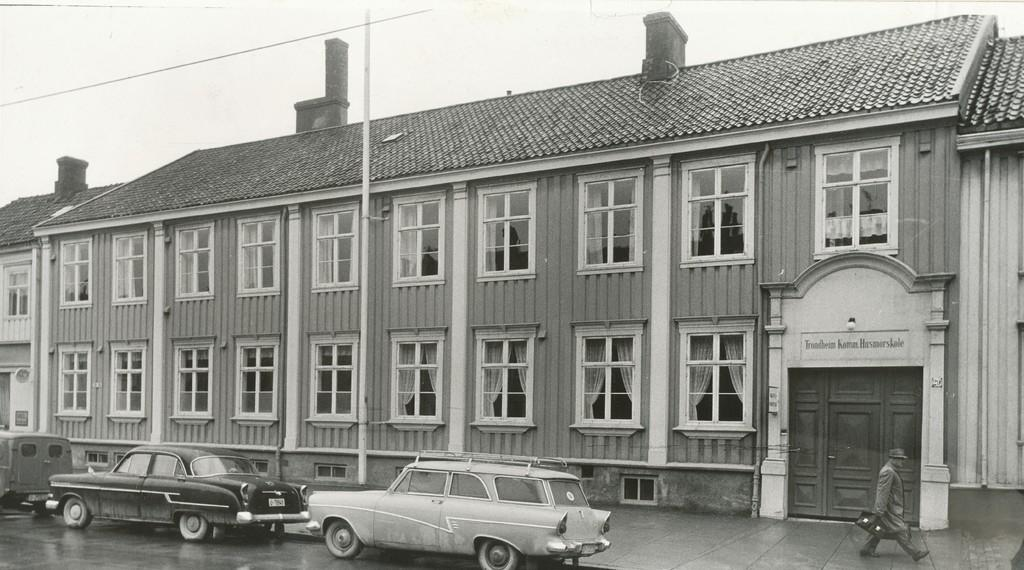What can be seen moving on the road in the image? There are vehicles on the road in the image. What is the person in the image doing? The person is walking and holding a bag. What is the tall, vertical object in the image? There is a pole in the image. What can be seen in the distance behind the vehicles and the person? There are buildings, windows, and the sky visible in the background. Can you tell me how many firemen are offering help in the image? There are no firemen or offers of help present in the image. What type of scale can be seen in the image? There is no scale or any other object mentioned in the facts, so it cannot be seen in the image. 